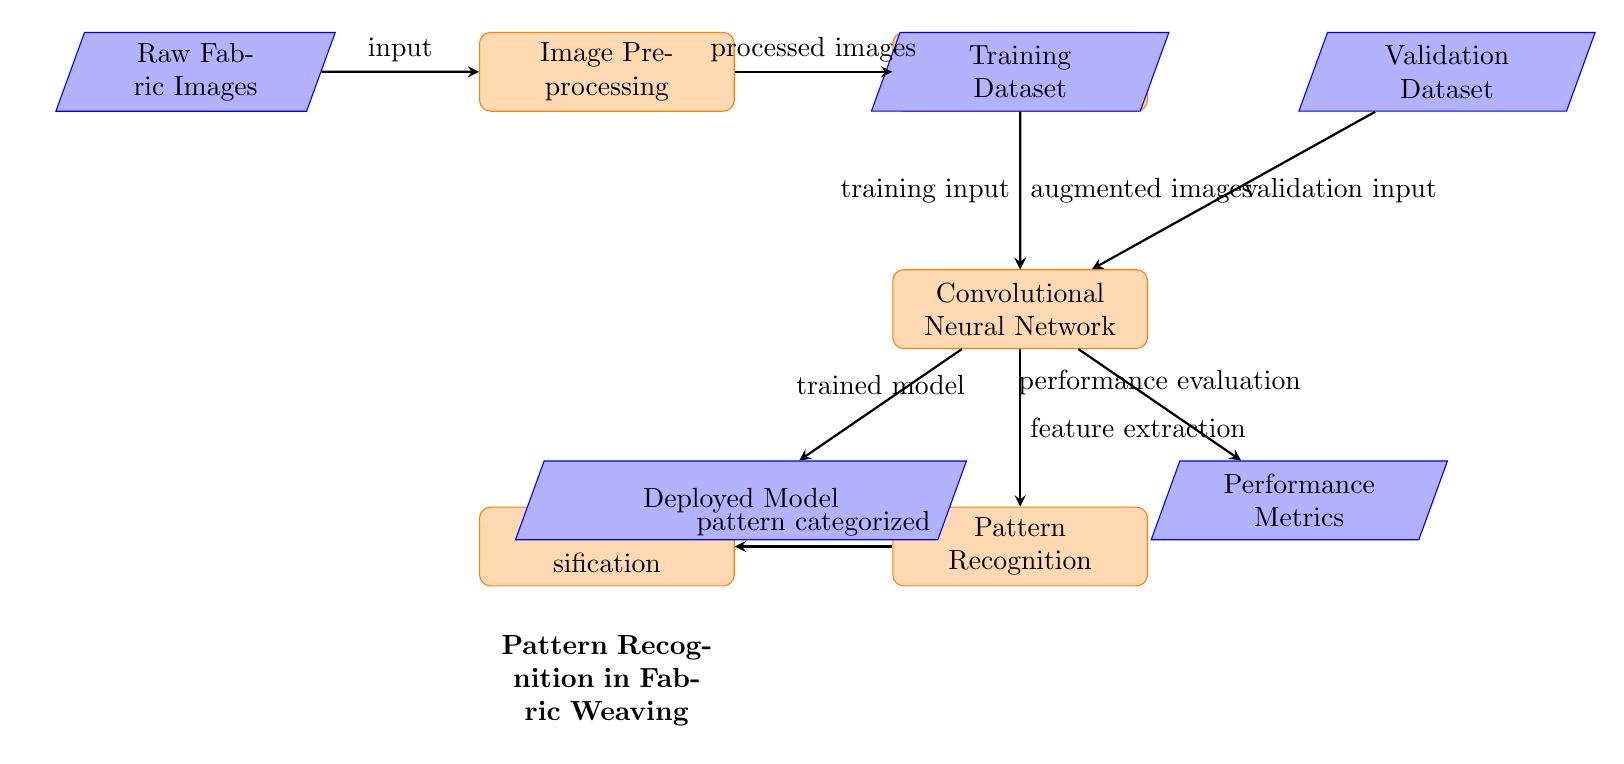What is the first step in the diagram? The first step in the diagram is represented by the node labeled "Raw Fabric Images." This is the starting point of the process where the input data is introduced.
Answer: Raw Fabric Images How many main processes are depicted in the diagram? The diagram contains four main processes: Image Preprocessing, Augmentation, Convolutional Neural Network, and Pattern Recognition. Counting these processes gives a total of four.
Answer: Four What type of data is used as input to the Convolutional Neural Network? The Convolutional Neural Network receives "augmented images" as its input, which are transformed through prior steps in the diagram.
Answer: Augmented images What is produced after the Pattern Recognition step? After the Pattern Recognition step, the diagram indicates that "Texture Classification" is produced. This step categorizes the recognized patterns.
Answer: Texture Classification What is the purpose of the Validation Dataset in the diagram? The Validation Dataset is used as "validation input" for the Convolutional Neural Network, helping to evaluate the model's performance by comparing its predictions against this dataset.
Answer: Validation input What are the two outputs produced by the Convolutional Neural Network? The two outputs produced by the Convolutional Neural Network are "Performance Metrics" and "Deployed Model." These represent the evaluation of the model and the model ready for use, respectively.
Answer: Performance Metrics and Deployed Model Which step follows Image Augmentation according to the diagram? According to the diagram, the step that follows Image Augmentation is the Convolutional Neural Network. This indicates that the augmented images are sent for further processing.
Answer: Convolutional Neural Network What indicates the conclusion of the process flow in the diagram? The conclusion of the process flow is indicated by the nodes "Performance Metrics" and "Deployed Model," representing the final outputs of the Pattern Recognition system in fabric weaving.
Answer: Performance Metrics and Deployed Model Which node is connected to both the Training Dataset and Validation Dataset? The node connected to both the Training Dataset and Validation Dataset is the Convolutional Neural Network, which utilizes both sets of images for training and validation.
Answer: Convolutional Neural Network 